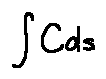Convert formula to latex. <formula><loc_0><loc_0><loc_500><loc_500>\int C d s</formula> 